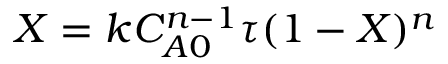Convert formula to latex. <formula><loc_0><loc_0><loc_500><loc_500>X = k C _ { A 0 } ^ { n - 1 } \tau ( 1 - X ) ^ { n }</formula> 